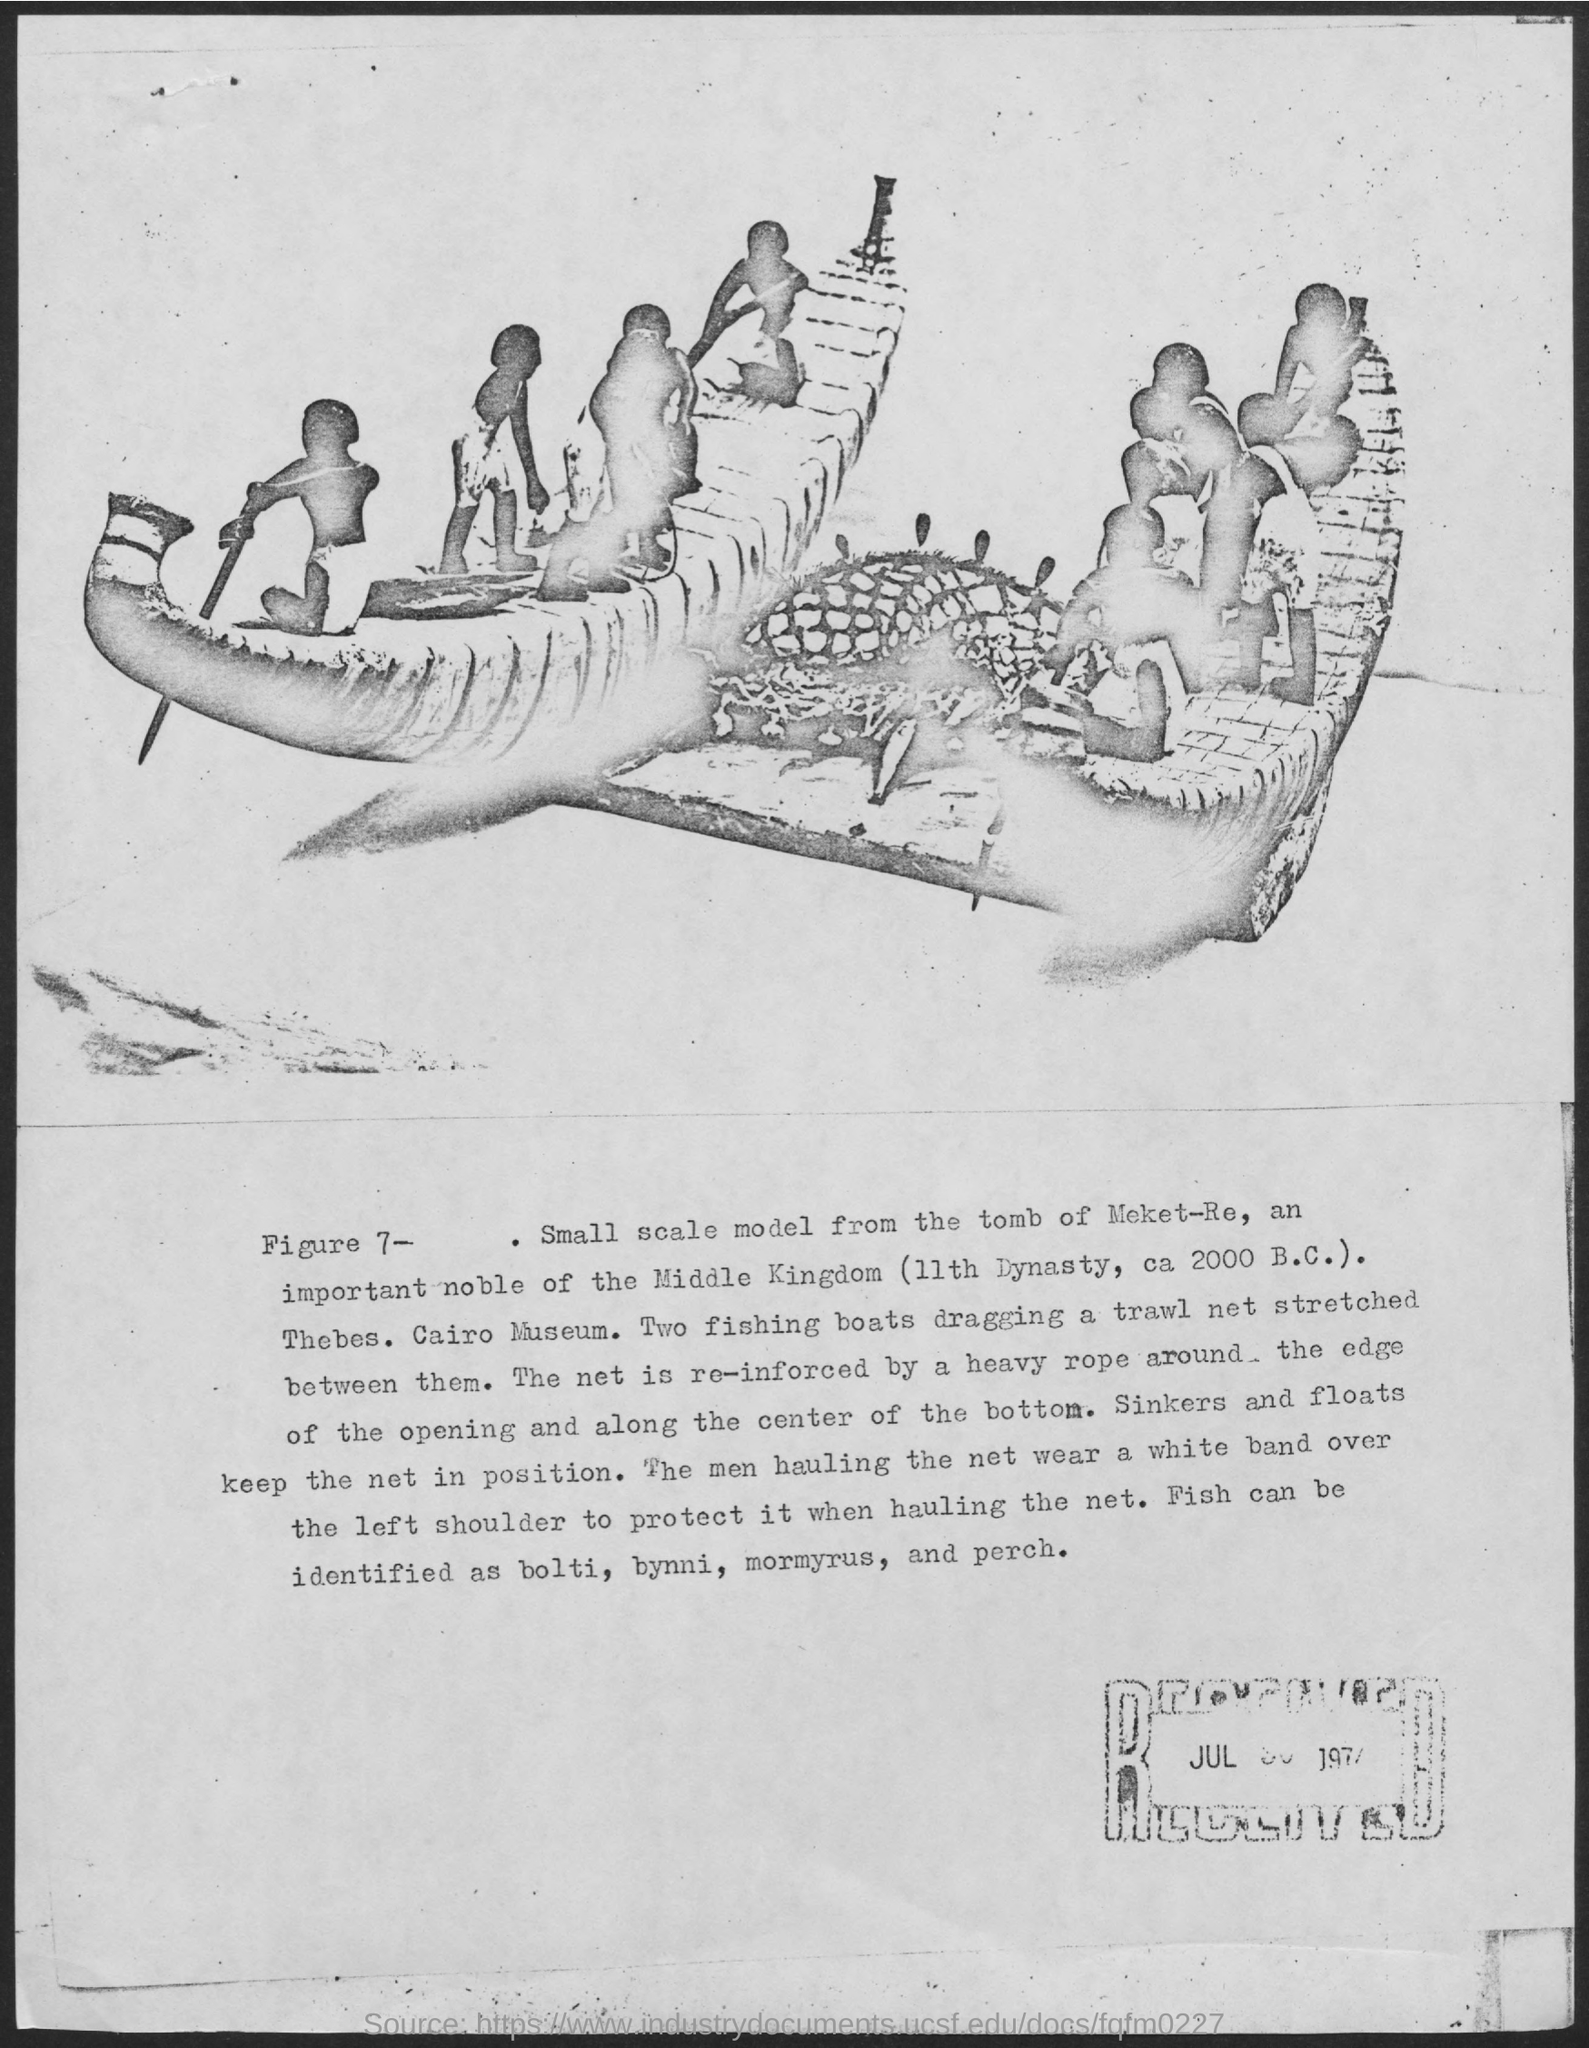Can you tell me what this image depicts? The image shows a small scale model from the tomb of Meket-Re, an important noble of the Middle Kingdom (11th Dynasty, ca. 2000 B.C.) located in Thebes. It is held in the Cairo Museum. The model represents two fishing boats dragging a trawl net with a heavy rope around the edge to keep it in position. It provides insight into fishing techniques and tools used during that era. 